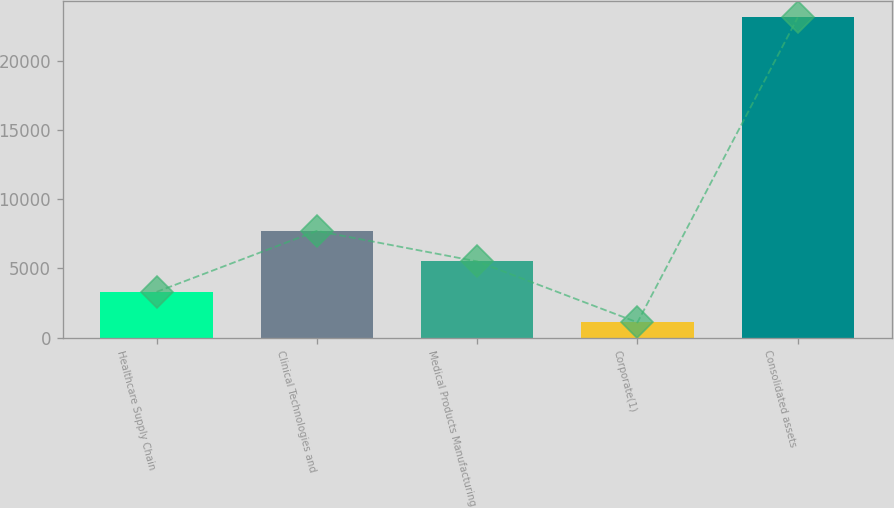Convert chart to OTSL. <chart><loc_0><loc_0><loc_500><loc_500><bar_chart><fcel>Healthcare Supply Chain<fcel>Clinical Technologies and<fcel>Medical Products Manufacturing<fcel>Corporate(1)<fcel>Consolidated assets<nl><fcel>3304.03<fcel>7715.09<fcel>5509.56<fcel>1098.5<fcel>23153.8<nl></chart> 